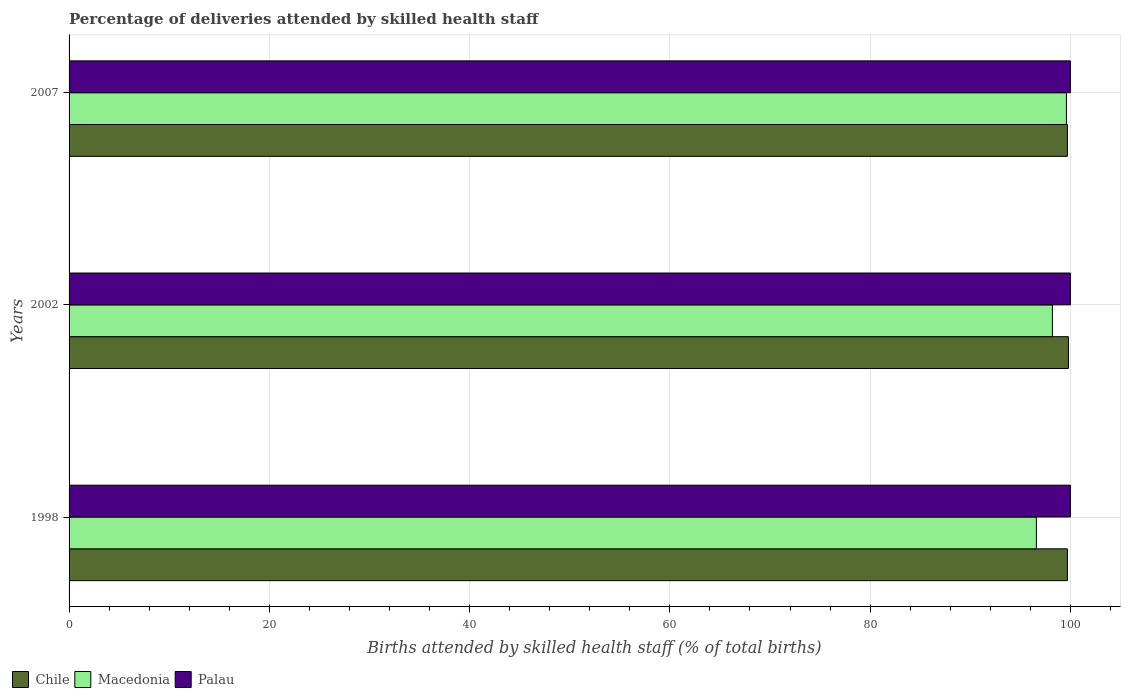How many groups of bars are there?
Your answer should be compact. 3. Are the number of bars per tick equal to the number of legend labels?
Make the answer very short. Yes. Are the number of bars on each tick of the Y-axis equal?
Your response must be concise. Yes. How many bars are there on the 1st tick from the top?
Ensure brevity in your answer.  3. How many bars are there on the 1st tick from the bottom?
Your answer should be compact. 3. What is the percentage of births attended by skilled health staff in Chile in 2002?
Give a very brief answer. 99.8. Across all years, what is the maximum percentage of births attended by skilled health staff in Palau?
Your response must be concise. 100. Across all years, what is the minimum percentage of births attended by skilled health staff in Chile?
Provide a succinct answer. 99.7. What is the total percentage of births attended by skilled health staff in Chile in the graph?
Your answer should be very brief. 299.2. What is the difference between the percentage of births attended by skilled health staff in Palau in 1998 and the percentage of births attended by skilled health staff in Chile in 2002?
Provide a short and direct response. 0.2. What is the average percentage of births attended by skilled health staff in Macedonia per year?
Give a very brief answer. 98.13. In the year 2002, what is the difference between the percentage of births attended by skilled health staff in Macedonia and percentage of births attended by skilled health staff in Palau?
Offer a very short reply. -1.8. What is the ratio of the percentage of births attended by skilled health staff in Macedonia in 1998 to that in 2007?
Ensure brevity in your answer.  0.97. What is the difference between the highest and the second highest percentage of births attended by skilled health staff in Macedonia?
Your response must be concise. 1.4. What is the difference between the highest and the lowest percentage of births attended by skilled health staff in Palau?
Your response must be concise. 0. In how many years, is the percentage of births attended by skilled health staff in Macedonia greater than the average percentage of births attended by skilled health staff in Macedonia taken over all years?
Your answer should be compact. 2. What does the 2nd bar from the top in 1998 represents?
Your answer should be compact. Macedonia. What does the 1st bar from the bottom in 2007 represents?
Offer a terse response. Chile. How many bars are there?
Ensure brevity in your answer.  9. How many years are there in the graph?
Your answer should be compact. 3. What is the difference between two consecutive major ticks on the X-axis?
Make the answer very short. 20. Are the values on the major ticks of X-axis written in scientific E-notation?
Your answer should be very brief. No. Does the graph contain any zero values?
Provide a short and direct response. No. Does the graph contain grids?
Keep it short and to the point. Yes. How many legend labels are there?
Provide a short and direct response. 3. How are the legend labels stacked?
Your answer should be compact. Horizontal. What is the title of the graph?
Ensure brevity in your answer.  Percentage of deliveries attended by skilled health staff. Does "Serbia" appear as one of the legend labels in the graph?
Give a very brief answer. No. What is the label or title of the X-axis?
Your response must be concise. Births attended by skilled health staff (% of total births). What is the Births attended by skilled health staff (% of total births) of Chile in 1998?
Offer a very short reply. 99.7. What is the Births attended by skilled health staff (% of total births) in Macedonia in 1998?
Offer a terse response. 96.6. What is the Births attended by skilled health staff (% of total births) of Palau in 1998?
Your answer should be very brief. 100. What is the Births attended by skilled health staff (% of total births) of Chile in 2002?
Your answer should be very brief. 99.8. What is the Births attended by skilled health staff (% of total births) in Macedonia in 2002?
Ensure brevity in your answer.  98.2. What is the Births attended by skilled health staff (% of total births) in Palau in 2002?
Offer a terse response. 100. What is the Births attended by skilled health staff (% of total births) in Chile in 2007?
Give a very brief answer. 99.7. What is the Births attended by skilled health staff (% of total births) in Macedonia in 2007?
Make the answer very short. 99.6. What is the Births attended by skilled health staff (% of total births) in Palau in 2007?
Offer a terse response. 100. Across all years, what is the maximum Births attended by skilled health staff (% of total births) of Chile?
Provide a short and direct response. 99.8. Across all years, what is the maximum Births attended by skilled health staff (% of total births) in Macedonia?
Your answer should be compact. 99.6. Across all years, what is the maximum Births attended by skilled health staff (% of total births) in Palau?
Make the answer very short. 100. Across all years, what is the minimum Births attended by skilled health staff (% of total births) in Chile?
Provide a succinct answer. 99.7. Across all years, what is the minimum Births attended by skilled health staff (% of total births) of Macedonia?
Provide a succinct answer. 96.6. Across all years, what is the minimum Births attended by skilled health staff (% of total births) in Palau?
Ensure brevity in your answer.  100. What is the total Births attended by skilled health staff (% of total births) in Chile in the graph?
Offer a very short reply. 299.2. What is the total Births attended by skilled health staff (% of total births) of Macedonia in the graph?
Make the answer very short. 294.4. What is the total Births attended by skilled health staff (% of total births) of Palau in the graph?
Provide a succinct answer. 300. What is the difference between the Births attended by skilled health staff (% of total births) in Macedonia in 1998 and that in 2002?
Offer a terse response. -1.6. What is the difference between the Births attended by skilled health staff (% of total births) in Palau in 1998 and that in 2002?
Your answer should be very brief. 0. What is the difference between the Births attended by skilled health staff (% of total births) in Palau in 1998 and that in 2007?
Your answer should be very brief. 0. What is the difference between the Births attended by skilled health staff (% of total births) in Macedonia in 2002 and that in 2007?
Offer a terse response. -1.4. What is the difference between the Births attended by skilled health staff (% of total births) of Palau in 2002 and that in 2007?
Make the answer very short. 0. What is the difference between the Births attended by skilled health staff (% of total births) in Chile in 1998 and the Births attended by skilled health staff (% of total births) in Palau in 2002?
Provide a succinct answer. -0.3. What is the difference between the Births attended by skilled health staff (% of total births) of Chile in 1998 and the Births attended by skilled health staff (% of total births) of Macedonia in 2007?
Your response must be concise. 0.1. What is the difference between the Births attended by skilled health staff (% of total births) of Chile in 1998 and the Births attended by skilled health staff (% of total births) of Palau in 2007?
Provide a short and direct response. -0.3. What is the difference between the Births attended by skilled health staff (% of total births) of Macedonia in 1998 and the Births attended by skilled health staff (% of total births) of Palau in 2007?
Ensure brevity in your answer.  -3.4. What is the difference between the Births attended by skilled health staff (% of total births) in Chile in 2002 and the Births attended by skilled health staff (% of total births) in Macedonia in 2007?
Offer a very short reply. 0.2. What is the difference between the Births attended by skilled health staff (% of total births) in Macedonia in 2002 and the Births attended by skilled health staff (% of total births) in Palau in 2007?
Give a very brief answer. -1.8. What is the average Births attended by skilled health staff (% of total births) of Chile per year?
Make the answer very short. 99.73. What is the average Births attended by skilled health staff (% of total births) of Macedonia per year?
Your answer should be compact. 98.13. What is the average Births attended by skilled health staff (% of total births) in Palau per year?
Give a very brief answer. 100. In the year 1998, what is the difference between the Births attended by skilled health staff (% of total births) of Chile and Births attended by skilled health staff (% of total births) of Macedonia?
Ensure brevity in your answer.  3.1. In the year 1998, what is the difference between the Births attended by skilled health staff (% of total births) in Chile and Births attended by skilled health staff (% of total births) in Palau?
Keep it short and to the point. -0.3. In the year 2002, what is the difference between the Births attended by skilled health staff (% of total births) in Chile and Births attended by skilled health staff (% of total births) in Macedonia?
Keep it short and to the point. 1.6. In the year 2002, what is the difference between the Births attended by skilled health staff (% of total births) in Macedonia and Births attended by skilled health staff (% of total births) in Palau?
Provide a short and direct response. -1.8. In the year 2007, what is the difference between the Births attended by skilled health staff (% of total births) in Macedonia and Births attended by skilled health staff (% of total births) in Palau?
Offer a very short reply. -0.4. What is the ratio of the Births attended by skilled health staff (% of total births) in Chile in 1998 to that in 2002?
Give a very brief answer. 1. What is the ratio of the Births attended by skilled health staff (% of total births) of Macedonia in 1998 to that in 2002?
Provide a short and direct response. 0.98. What is the ratio of the Births attended by skilled health staff (% of total births) of Palau in 1998 to that in 2002?
Provide a succinct answer. 1. What is the ratio of the Births attended by skilled health staff (% of total births) in Chile in 1998 to that in 2007?
Your answer should be compact. 1. What is the ratio of the Births attended by skilled health staff (% of total births) in Macedonia in 1998 to that in 2007?
Keep it short and to the point. 0.97. What is the ratio of the Births attended by skilled health staff (% of total births) of Palau in 1998 to that in 2007?
Provide a succinct answer. 1. What is the ratio of the Births attended by skilled health staff (% of total births) in Chile in 2002 to that in 2007?
Provide a short and direct response. 1. What is the ratio of the Births attended by skilled health staff (% of total births) of Macedonia in 2002 to that in 2007?
Your response must be concise. 0.99. What is the difference between the highest and the second highest Births attended by skilled health staff (% of total births) in Macedonia?
Offer a terse response. 1.4. What is the difference between the highest and the lowest Births attended by skilled health staff (% of total births) in Palau?
Keep it short and to the point. 0. 